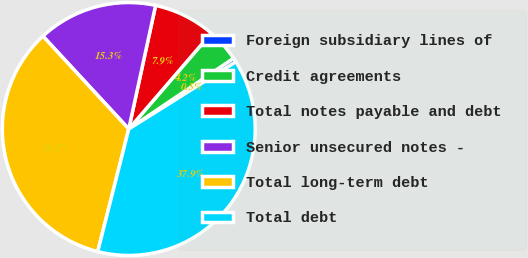Convert chart. <chart><loc_0><loc_0><loc_500><loc_500><pie_chart><fcel>Foreign subsidiary lines of<fcel>Credit agreements<fcel>Total notes payable and debt<fcel>Senior unsecured notes -<fcel>Total long-term debt<fcel>Total debt<nl><fcel>0.54%<fcel>4.23%<fcel>7.91%<fcel>15.28%<fcel>34.18%<fcel>37.86%<nl></chart> 